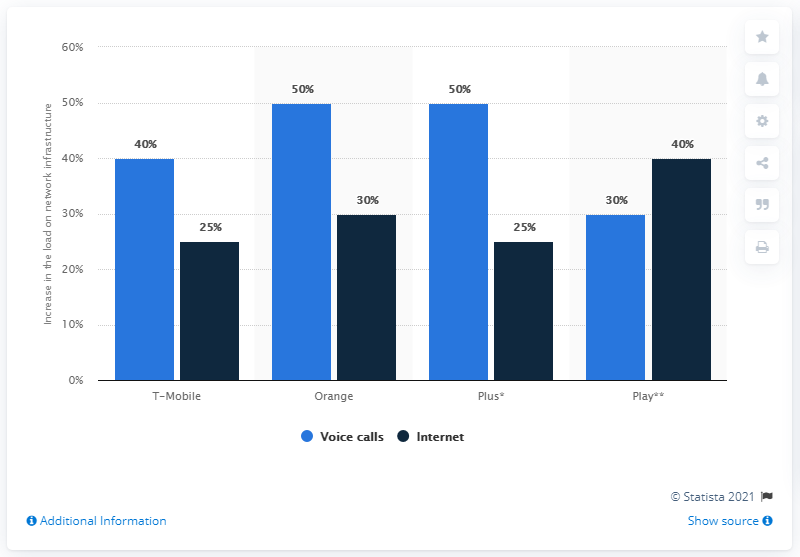Indicate a few pertinent items in this graphic. The use of data on the Play mobile network increased by 40%. 